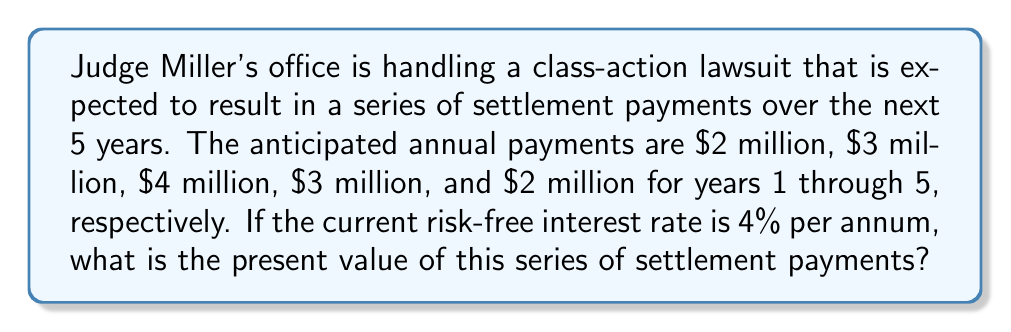Show me your answer to this math problem. To calculate the present value of the future legal settlements, we need to discount each future payment back to the present using the given interest rate. We'll use the present value formula for a series of uneven cash flows:

$$ PV = \sum_{t=1}^{n} \frac{CF_t}{(1+r)^t} $$

Where:
$PV$ = Present Value
$CF_t$ = Cash Flow at time $t$
$r$ = Interest rate (as a decimal)
$n$ = Number of periods

Let's calculate the present value of each payment:

Year 1: $\frac{2,000,000}{(1+0.04)^1} = \frac{2,000,000}{1.04} = 1,923,076.92$

Year 2: $\frac{3,000,000}{(1+0.04)^2} = \frac{3,000,000}{1.0816} = 2,773,669.72$

Year 3: $\frac{4,000,000}{(1+0.04)^3} = \frac{4,000,000}{1.124864} = 3,555,621.30$

Year 4: $\frac{3,000,000}{(1+0.04)^4} = \frac{3,000,000}{1.16986} = 2,564,438.72$

Year 5: $\frac{2,000,000}{(1+0.04)^5} = \frac{2,000,000}{1.21665} = 1,643,805.97$

Now, we sum up all these present values:

$$ PV_{total} = 1,923,076.92 + 2,773,669.72 + 3,555,621.30 + 2,564,438.72 + 1,643,805.97 $$
Answer: $12,460,612.63

The present value of the series of settlement payments is $12,460,612.63. 